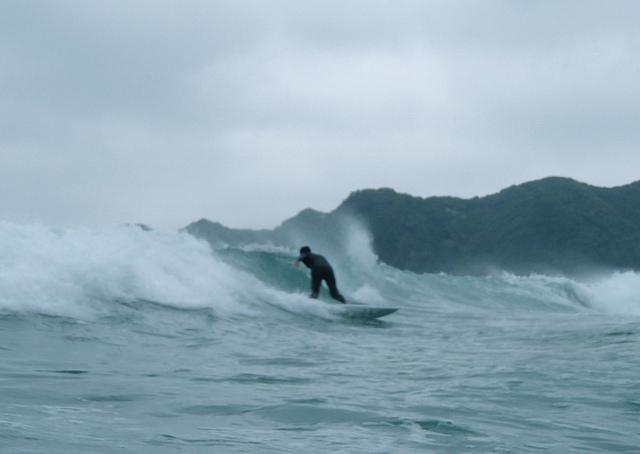What is the person doing?
Short answer required. Surfing. Is this a winter scene?
Be succinct. No. How big is that wave?
Be succinct. Medium. Is he surfing by himself?
Give a very brief answer. Yes. Which direction is the surfer looking?
Quick response, please. Left. Where is the person at?
Answer briefly. Ocean. What color is the wave?
Give a very brief answer. Blue. Did the surfer go under the wave?
Quick response, please. No. What is the man wearing?
Concise answer only. Wetsuit. On which beach was this picture taken?
Give a very brief answer. Sandy hook. How many feet does the man have on the surfboard?
Write a very short answer. 2. Are the waves killer?
Give a very brief answer. No. 